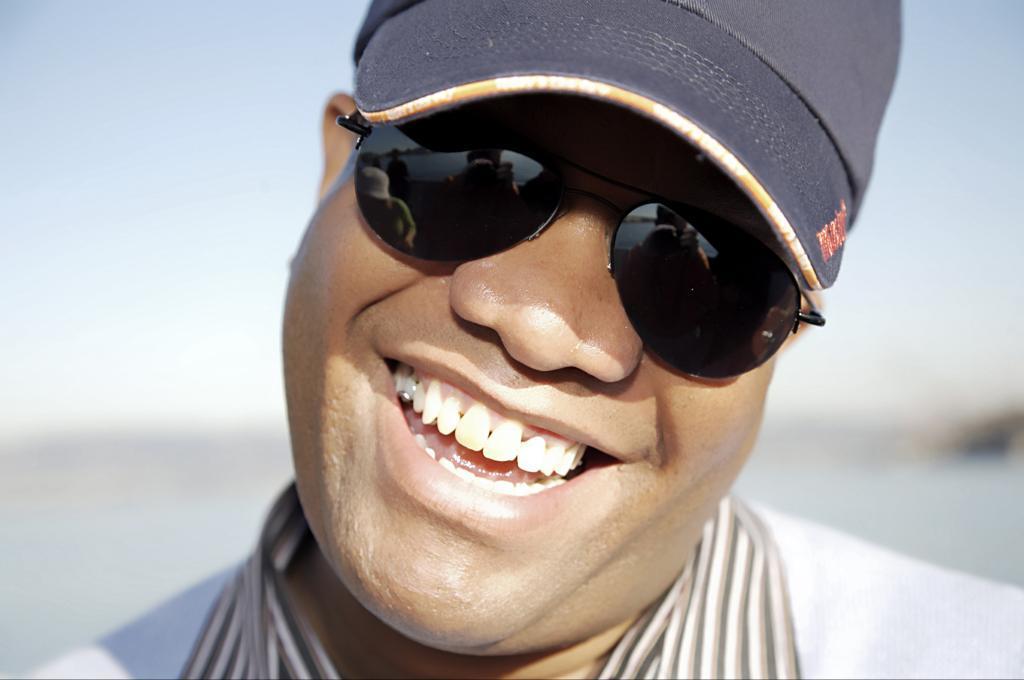In one or two sentences, can you explain what this image depicts? In this image I can see a person smiling. He is wearing spectacles and a cap. The background is blurred. 